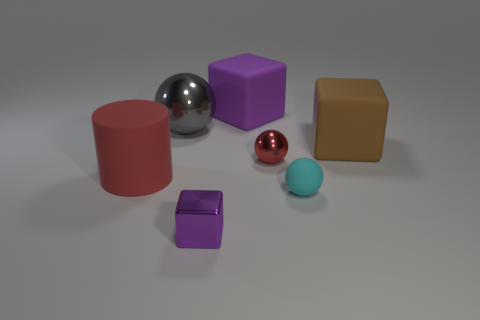There is a red object that is on the right side of the thing that is behind the big metal object; what is its shape? The red object situated to the right of the item behind the large metallic sphere is cylindrical in shape, resembling a short, stout pillar. 